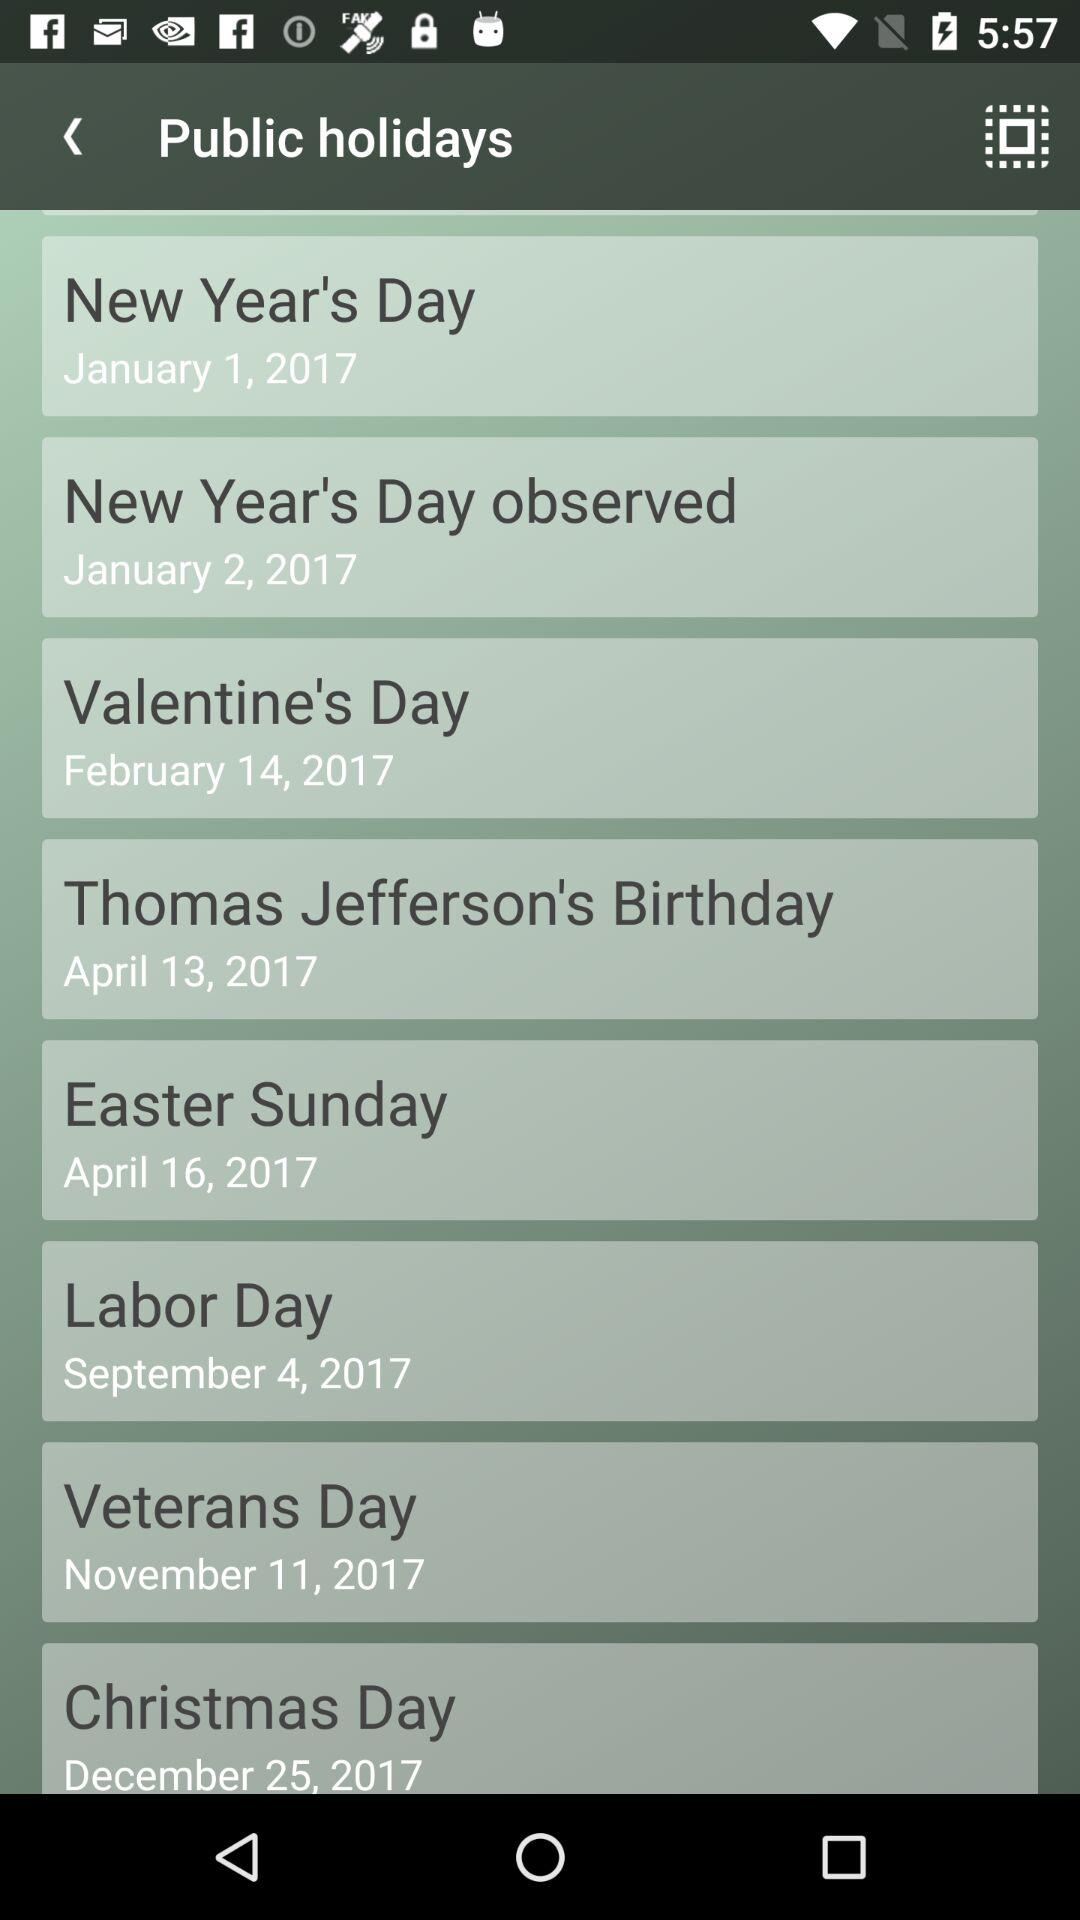What date is mentioned for Easter Day? The date is April 16, 2017. 